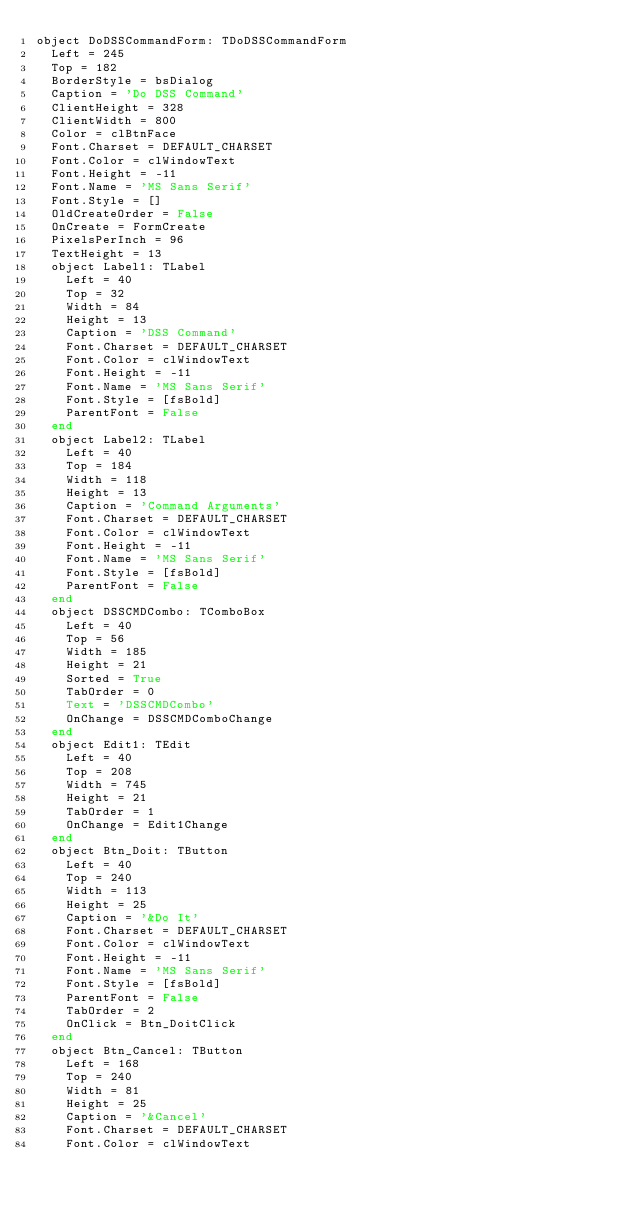Convert code to text. <code><loc_0><loc_0><loc_500><loc_500><_Pascal_>object DoDSSCommandForm: TDoDSSCommandForm
  Left = 245
  Top = 182
  BorderStyle = bsDialog
  Caption = 'Do DSS Command'
  ClientHeight = 328
  ClientWidth = 800
  Color = clBtnFace
  Font.Charset = DEFAULT_CHARSET
  Font.Color = clWindowText
  Font.Height = -11
  Font.Name = 'MS Sans Serif'
  Font.Style = []
  OldCreateOrder = False
  OnCreate = FormCreate
  PixelsPerInch = 96
  TextHeight = 13
  object Label1: TLabel
    Left = 40
    Top = 32
    Width = 84
    Height = 13
    Caption = 'DSS Command'
    Font.Charset = DEFAULT_CHARSET
    Font.Color = clWindowText
    Font.Height = -11
    Font.Name = 'MS Sans Serif'
    Font.Style = [fsBold]
    ParentFont = False
  end
  object Label2: TLabel
    Left = 40
    Top = 184
    Width = 118
    Height = 13
    Caption = 'Command Arguments'
    Font.Charset = DEFAULT_CHARSET
    Font.Color = clWindowText
    Font.Height = -11
    Font.Name = 'MS Sans Serif'
    Font.Style = [fsBold]
    ParentFont = False
  end
  object DSSCMDCombo: TComboBox
    Left = 40
    Top = 56
    Width = 185
    Height = 21
    Sorted = True
    TabOrder = 0
    Text = 'DSSCMDCombo'
    OnChange = DSSCMDComboChange
  end
  object Edit1: TEdit
    Left = 40
    Top = 208
    Width = 745
    Height = 21
    TabOrder = 1
    OnChange = Edit1Change
  end
  object Btn_Doit: TButton
    Left = 40
    Top = 240
    Width = 113
    Height = 25
    Caption = '&Do It'
    Font.Charset = DEFAULT_CHARSET
    Font.Color = clWindowText
    Font.Height = -11
    Font.Name = 'MS Sans Serif'
    Font.Style = [fsBold]
    ParentFont = False
    TabOrder = 2
    OnClick = Btn_DoitClick
  end
  object Btn_Cancel: TButton
    Left = 168
    Top = 240
    Width = 81
    Height = 25
    Caption = '&Cancel'
    Font.Charset = DEFAULT_CHARSET
    Font.Color = clWindowText</code> 